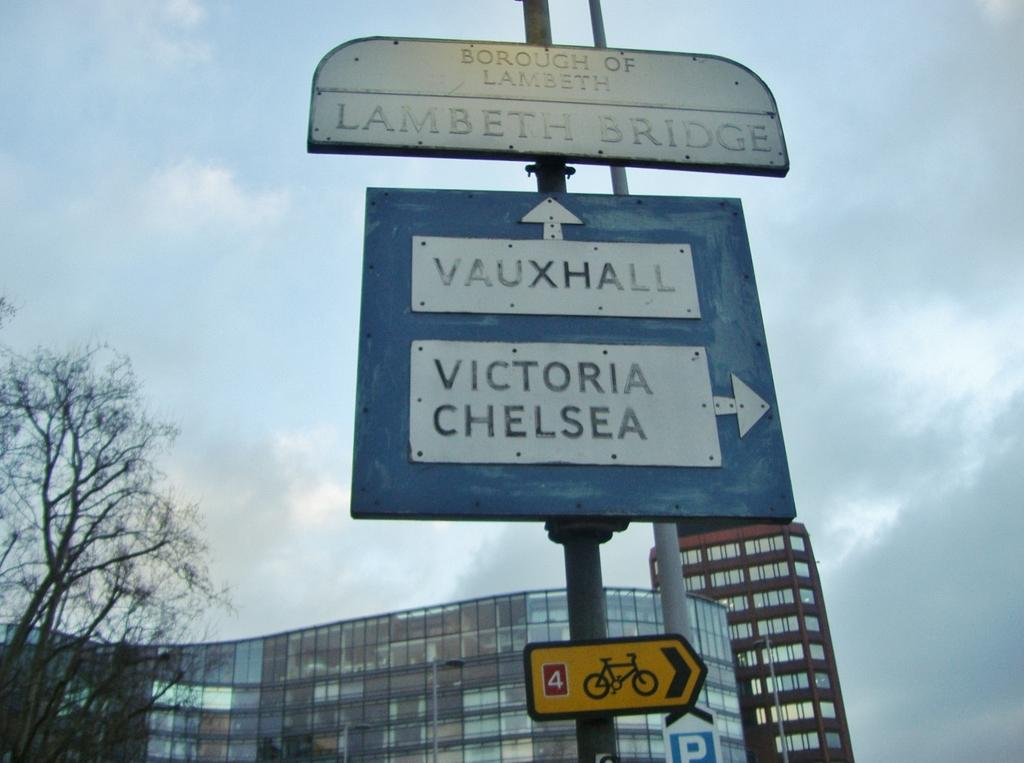<image>
Present a compact description of the photo's key features. A sign for Lambeth Bridge gives directions to Vauxhall & Victoria and Chelsea. 